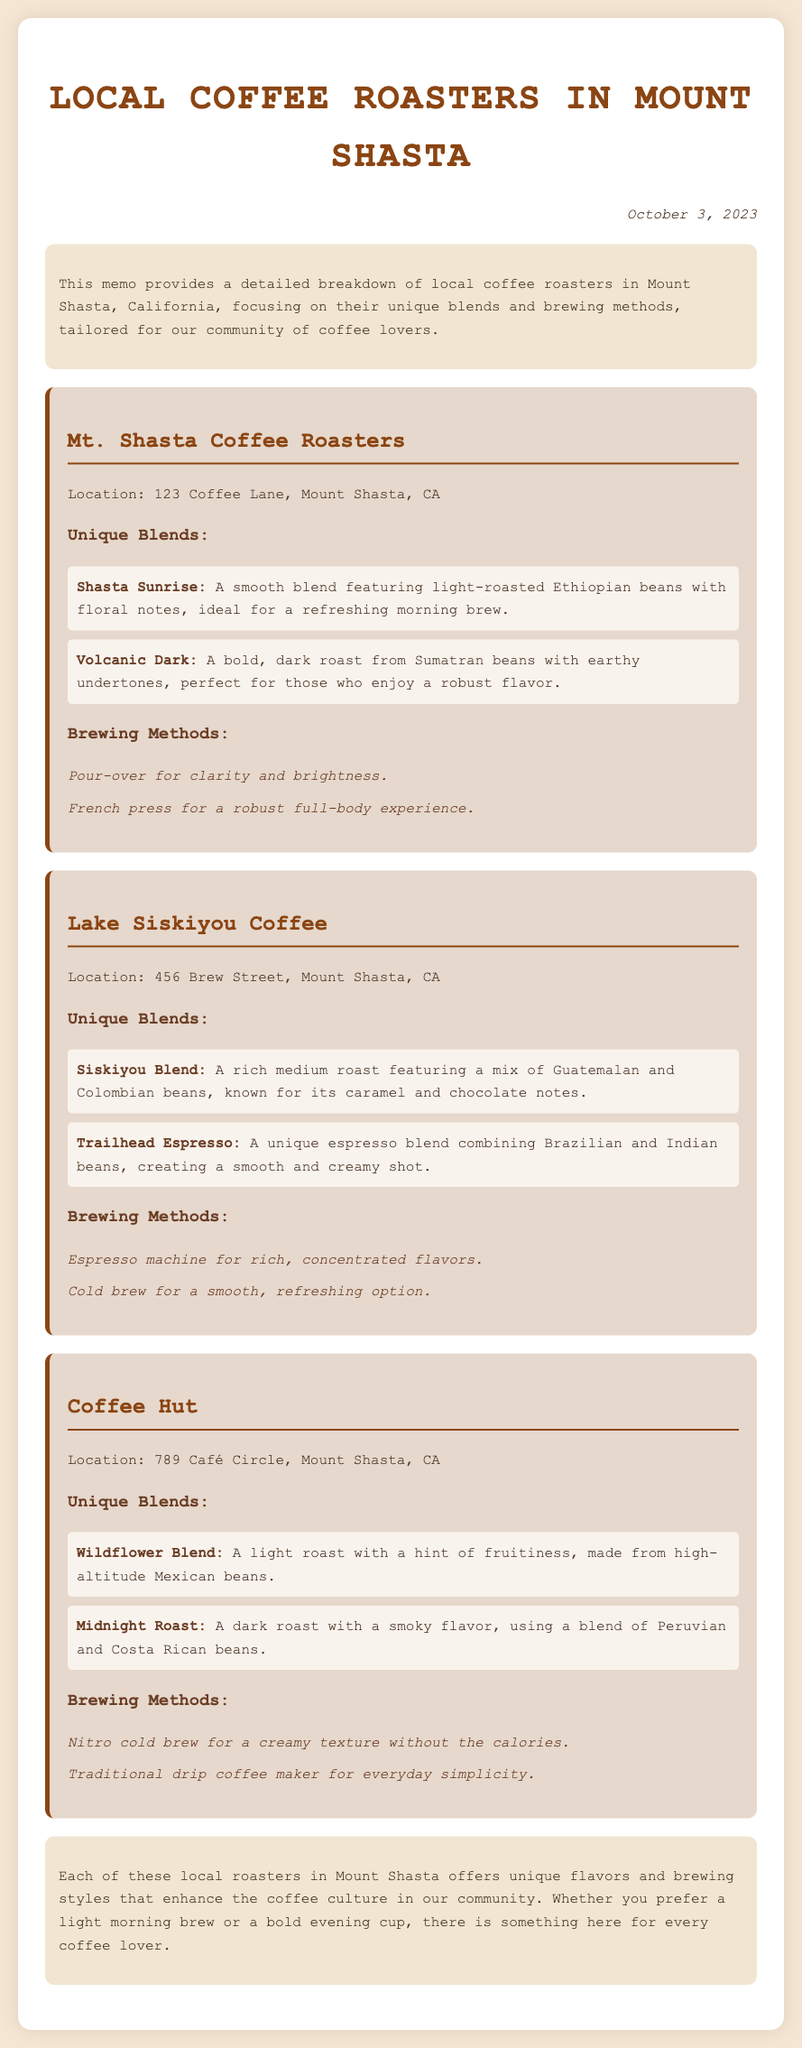What is the name of the first coffee roaster? The first coffee roaster mentioned in the document is "Mt. Shasta Coffee Roasters."
Answer: Mt. Shasta Coffee Roasters What is the location of Lake Siskiyou Coffee? Lake Siskiyou Coffee is located at "456 Brew Street, Mount Shasta, CA."
Answer: 456 Brew Street, Mount Shasta, CA What unique blend does Coffee Hut offer? The document lists "Wildflower Blend" as a unique blend offered by Coffee Hut.
Answer: Wildflower Blend What brewing method is used by Mt. Shasta Coffee Roasters for clarity? The brewing method used is "Pour-over."
Answer: Pour-over Which blend features Guatemalan and Colombian beans? The blend that features these beans is called "Siskiyou Blend."
Answer: Siskiyou Blend How many unique blends does Lake Siskiyou Coffee have? Lake Siskiyou Coffee offers two unique blends mentioned in the document.
Answer: Two What is the brewing method for Cold brew at Lake Siskiyou Coffee? The brewing method used for Cold brew is specified as "smooth, refreshing option."
Answer: Cold brew What is the date of the memo? The memo is dated "October 3, 2023."
Answer: October 3, 2023 Which local coffee roaster specializes in nitrogen-infused coffee? The roaster that specializes in this method is "Coffee Hut."
Answer: Coffee Hut 